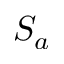Convert formula to latex. <formula><loc_0><loc_0><loc_500><loc_500>S _ { a }</formula> 